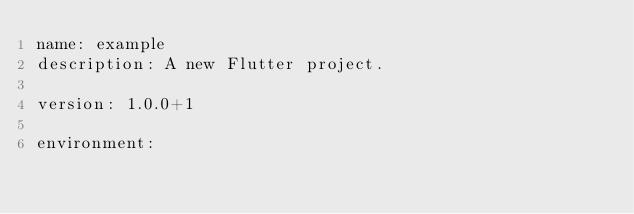Convert code to text. <code><loc_0><loc_0><loc_500><loc_500><_YAML_>name: example
description: A new Flutter project.

version: 1.0.0+1

environment:</code> 